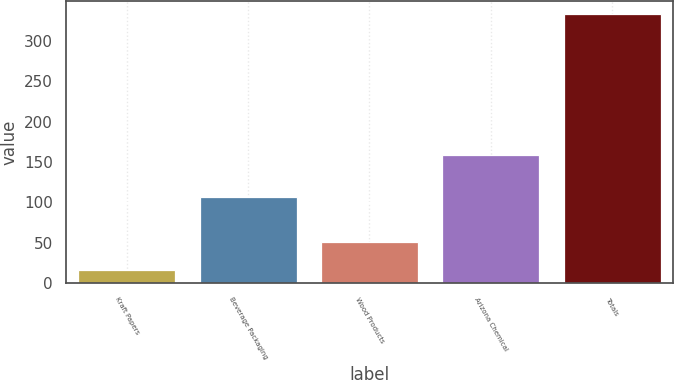Convert chart to OTSL. <chart><loc_0><loc_0><loc_500><loc_500><bar_chart><fcel>Kraft Papers<fcel>Beverage Packaging<fcel>Wood Products<fcel>Arizona Chemical<fcel>Totals<nl><fcel>16<fcel>107<fcel>51<fcel>159<fcel>333<nl></chart> 